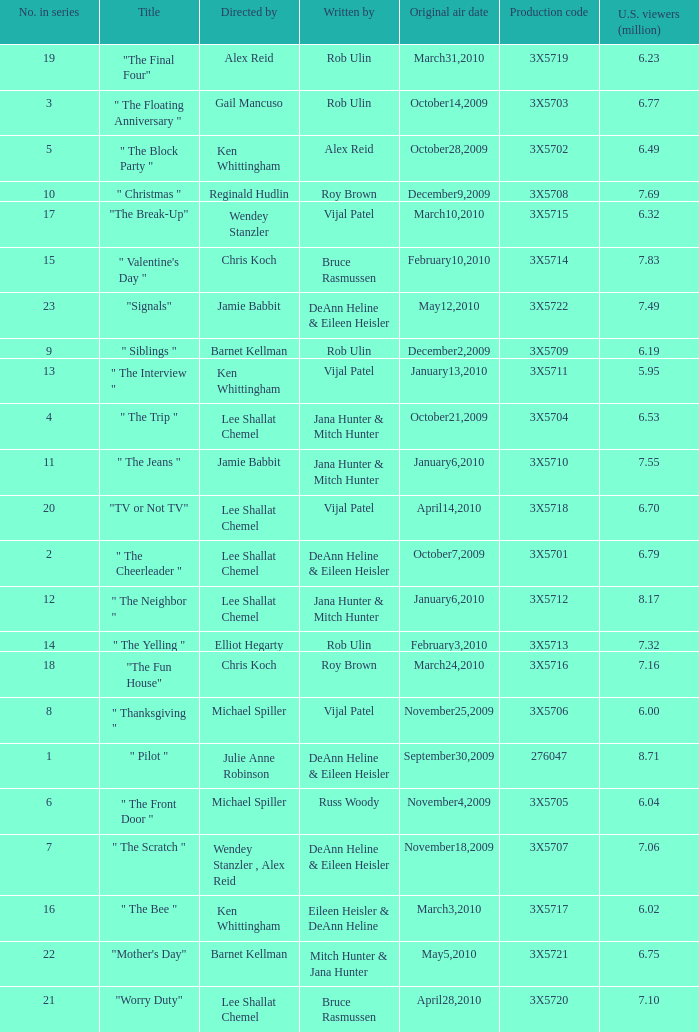How many directors got 6.79 million U.S. viewers from their episodes? 1.0. 